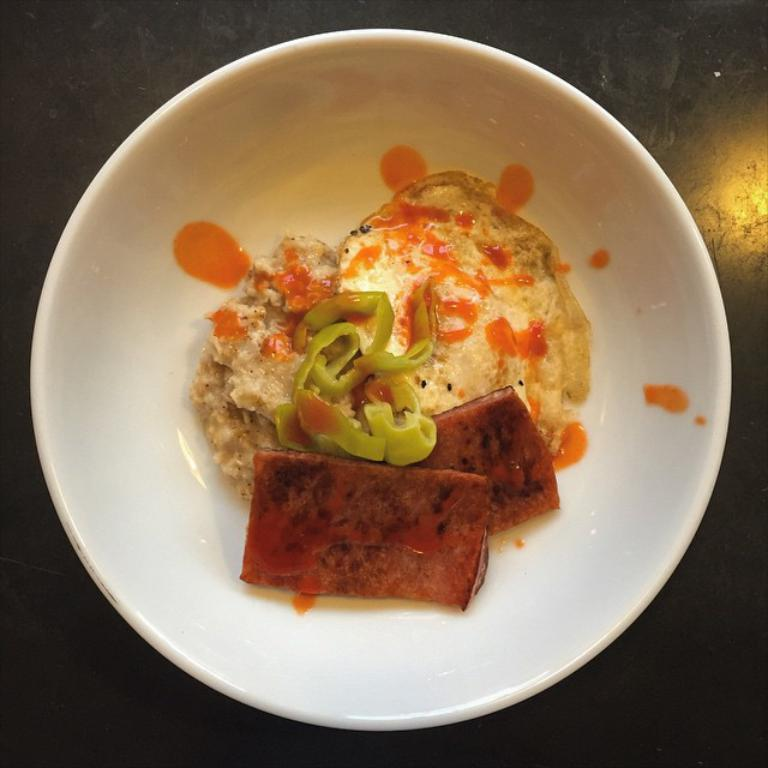What type of food is in the bowl in the image? The food in the bowl has brown, green, orange, and cream colors, but the specific type of food cannot be determined from the image alone. What color is the bowl in the image? The bowl is white. What color is the surface the bowl is sitting on? The surface is black. What effect does the pig have on the nail in the image? There is no pig or nail present in the image, so this question cannot be answered. 